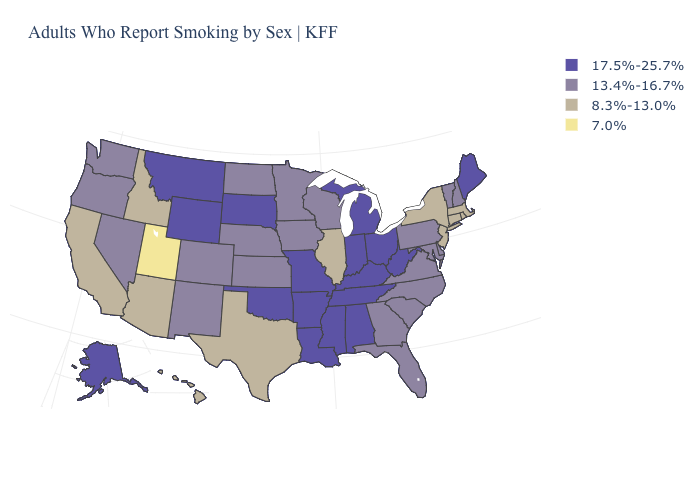What is the value of California?
Answer briefly. 8.3%-13.0%. What is the value of Pennsylvania?
Answer briefly. 13.4%-16.7%. What is the value of Oklahoma?
Write a very short answer. 17.5%-25.7%. Does Utah have the lowest value in the USA?
Give a very brief answer. Yes. What is the value of Maine?
Keep it brief. 17.5%-25.7%. Does Indiana have a higher value than New Jersey?
Write a very short answer. Yes. Is the legend a continuous bar?
Short answer required. No. What is the value of Oklahoma?
Be succinct. 17.5%-25.7%. How many symbols are there in the legend?
Quick response, please. 4. Does Mississippi have a lower value than Massachusetts?
Keep it brief. No. Does Tennessee have the lowest value in the South?
Concise answer only. No. What is the highest value in states that border Wisconsin?
Be succinct. 17.5%-25.7%. Does Kansas have the highest value in the MidWest?
Be succinct. No. Among the states that border New Hampshire , which have the highest value?
Concise answer only. Maine. What is the value of California?
Be succinct. 8.3%-13.0%. 